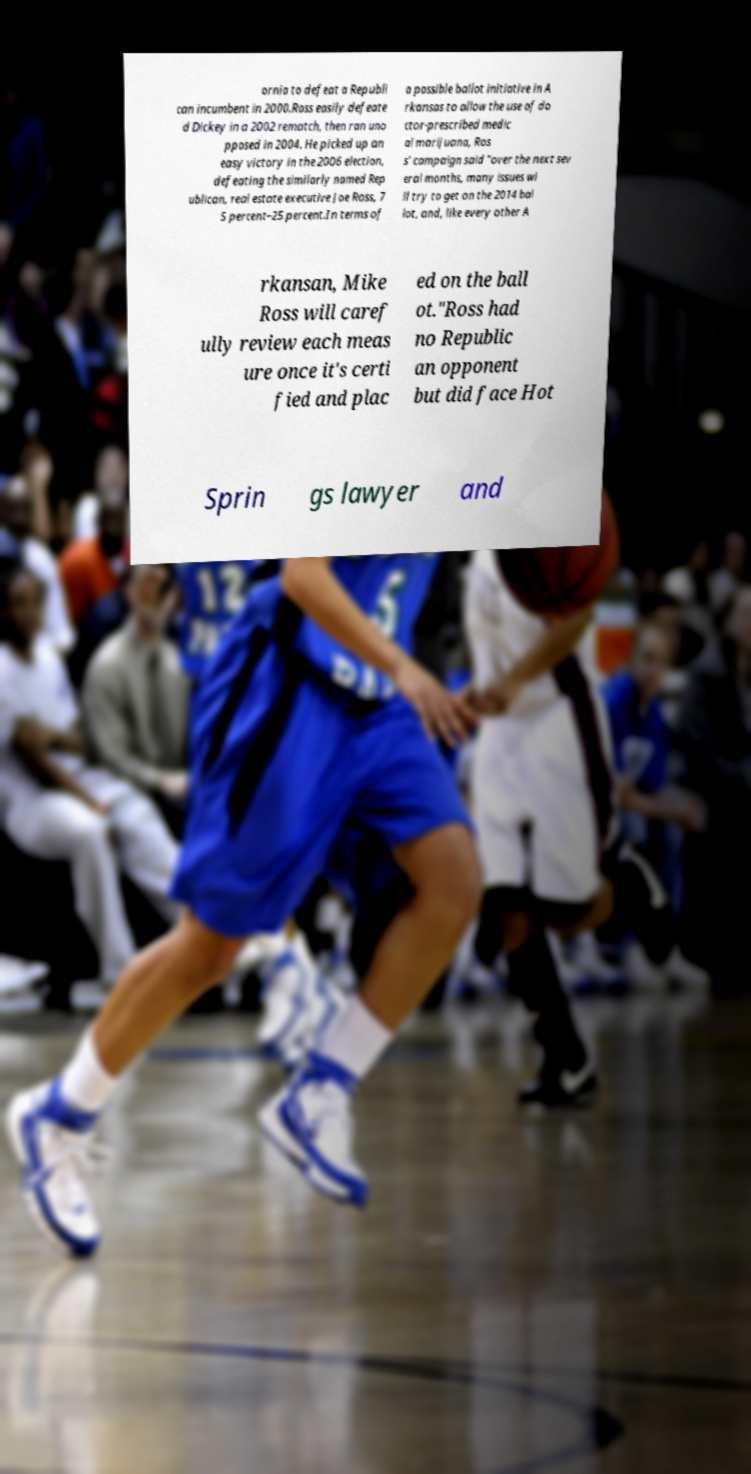For documentation purposes, I need the text within this image transcribed. Could you provide that? ornia to defeat a Republi can incumbent in 2000.Ross easily defeate d Dickey in a 2002 rematch, then ran uno pposed in 2004. He picked up an easy victory in the 2006 election, defeating the similarly named Rep ublican, real estate executive Joe Ross, 7 5 percent–25 percent.In terms of a possible ballot initiative in A rkansas to allow the use of do ctor-prescribed medic al marijuana, Ros s' campaign said "over the next sev eral months, many issues wi ll try to get on the 2014 bal lot, and, like every other A rkansan, Mike Ross will caref ully review each meas ure once it's certi fied and plac ed on the ball ot."Ross had no Republic an opponent but did face Hot Sprin gs lawyer and 